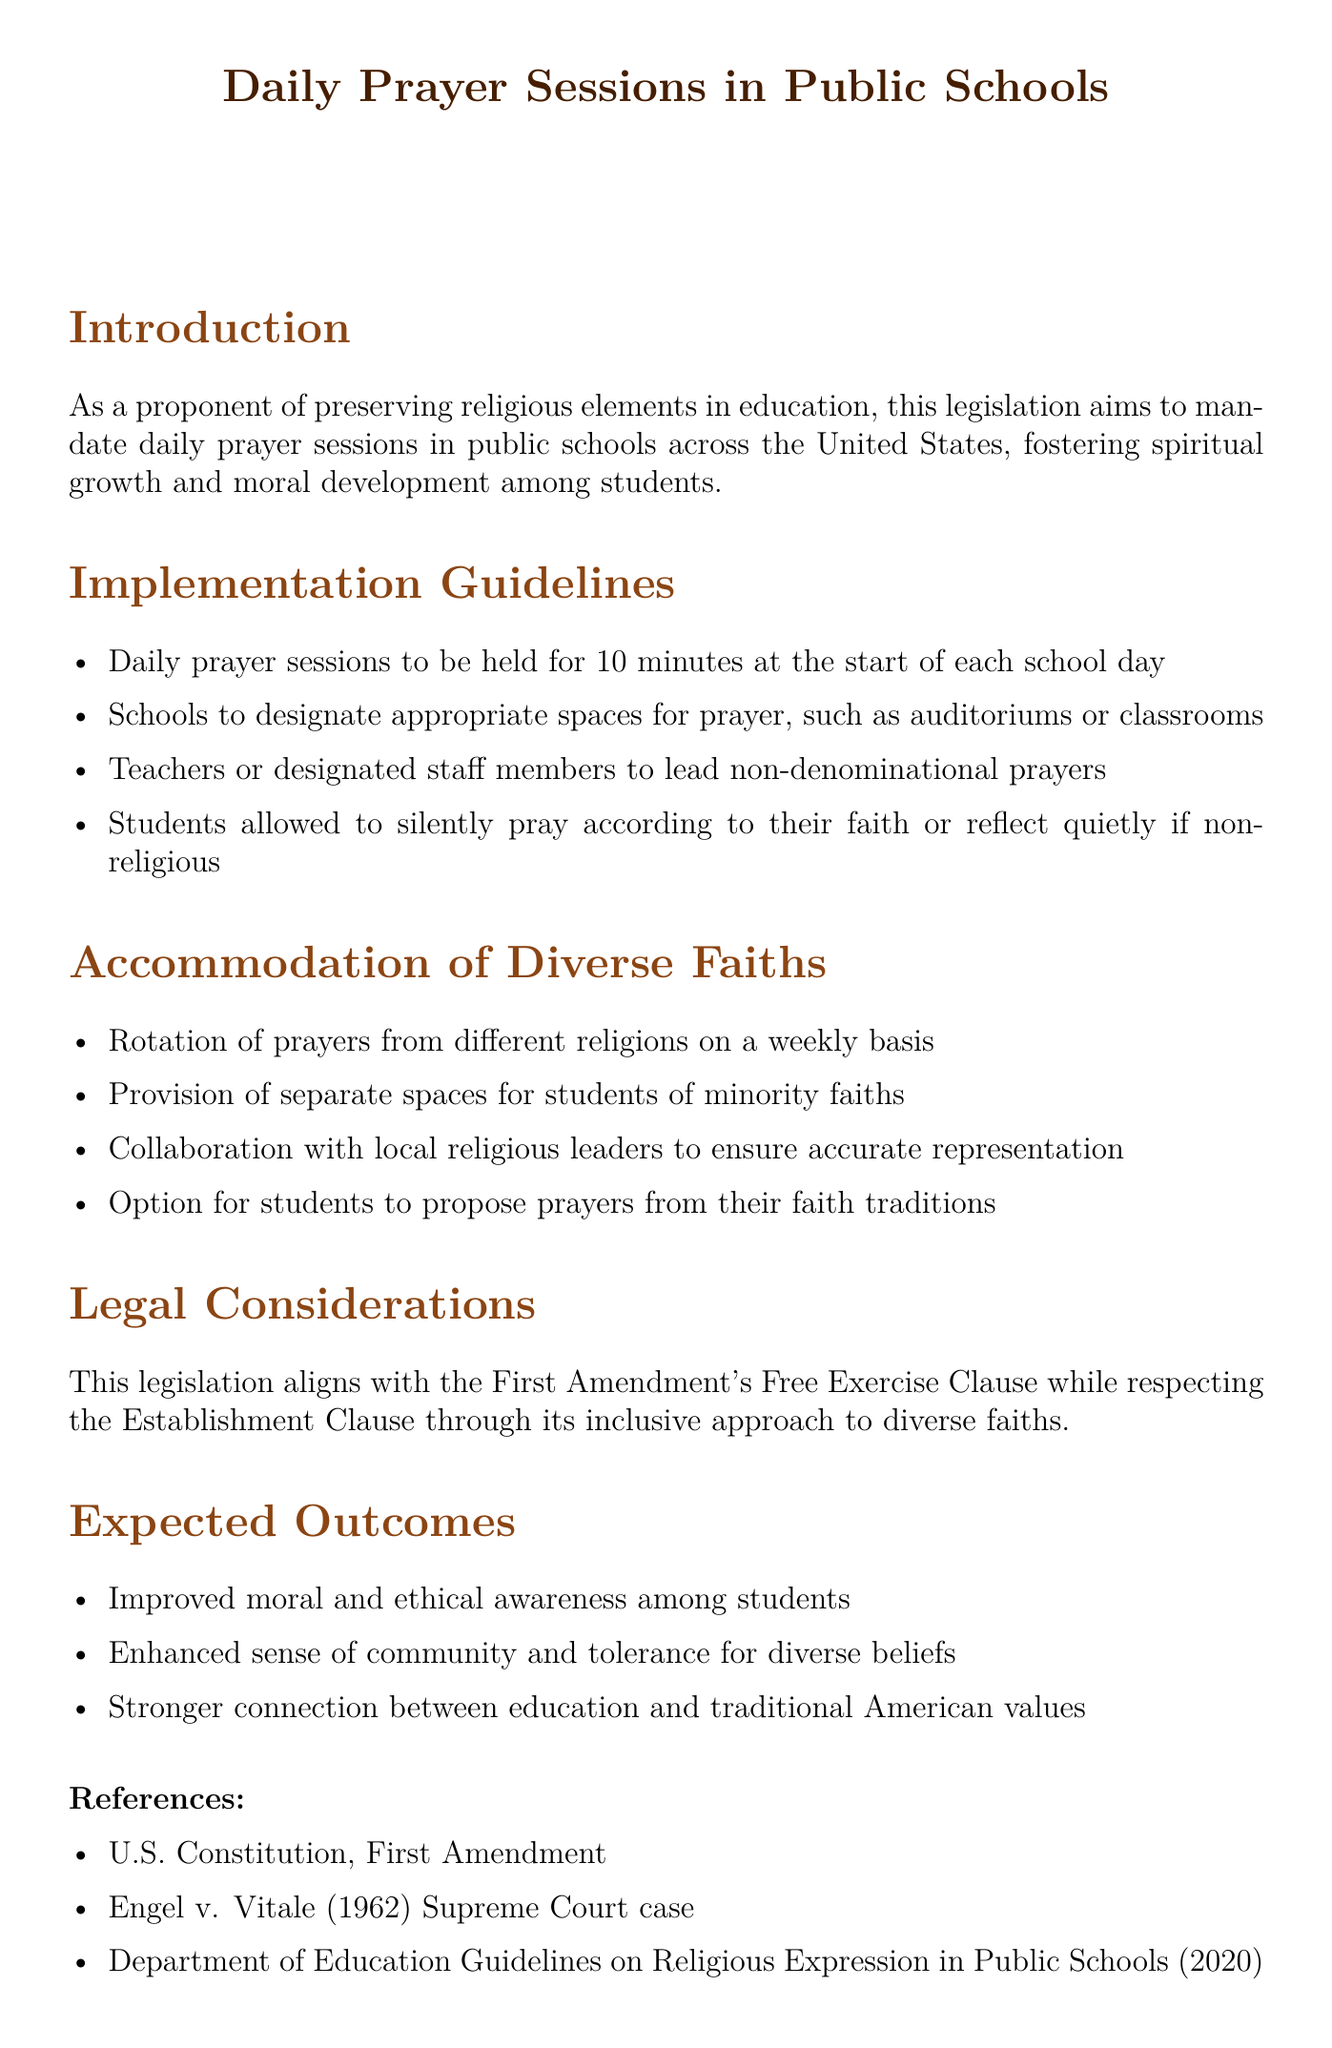What is the duration of daily prayer sessions? The duration of daily prayer sessions is specified as 10 minutes at the start of each school day.
Answer: 10 minutes What spaces are designated for prayer in schools? Schools are instructed to designate appropriate spaces for prayer, such as auditoriums or classrooms.
Answer: Auditoriums or classrooms How often will prayers from different religions be rotated? The document mentions that the rotation of prayers from different religions will occur on a weekly basis.
Answer: Weekly What is the primary aim of this legislation? The primary aim of this legislation is to foster spiritual growth and moral development among students.
Answer: Spiritual growth and moral development What legal clause does the legislation align with? The legislation aligns with the First Amendment's Free Exercise Clause.
Answer: First Amendment's Free Exercise Clause What is one expected outcome of implementing this legislation? One expected outcome is improved moral and ethical awareness among students.
Answer: Improved moral and ethical awareness Who can lead the non-denominational prayers? Teachers or designated staff members are to lead the non-denominational prayers.
Answer: Teachers or designated staff members What do students of minority faiths have provision for? Students of minority faiths have a provision for separate spaces.
Answer: Separate spaces How will collaboration be ensured for accurate representation? Collaboration with local religious leaders will be ensured for accurate representation.
Answer: Local religious leaders 